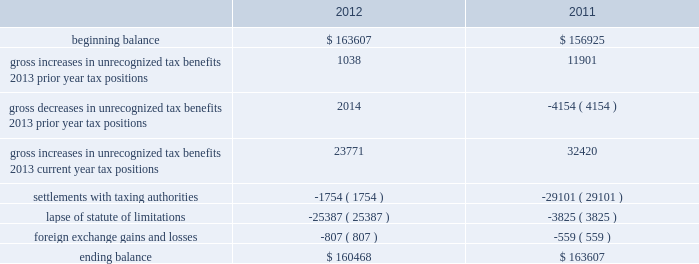Repatriated , the related u.s .
Tax liability may be reduced by any foreign income taxes paid on these earnings .
As of november 30 , 2012 , the cumulative amount of earnings upon which u.s .
Income taxes have not been provided is approximately $ 2.9 billion .
The unrecognized deferred tax liability for these earnings is approximately $ 0.8 billion .
As of november 30 , 2012 , we have u.s .
Net operating loss carryforwards of approximately $ 33.7 million for federal and $ 77.7 million for state .
We also have federal , state and foreign tax credit carryforwards of approximately $ 1.9 million , $ 18.0 million and $ 17.6 million , respectively .
The net operating loss carryforward assets , federal tax credits and foreign tax credits will expire in various years from fiscal 2017 through 2032 .
The state tax credit carryforwards can be carried forward indefinitely .
The net operating loss carryforward assets and certain credits are subject to an annual limitation under internal revenue code section 382 , but are expected to be fully realized .
In addition , we have been tracking certain deferred tax attributes of $ 45.0 million which have not been recorded in the financial statements pursuant to accounting standards related to stock-based compensation .
These amounts are no longer included in our gross or net deferred tax assets .
Pursuant to these standards , the benefit of these deferred tax assets will be recorded to equity if and when they reduce taxes payable .
As of november 30 , 2012 , a valuation allowance of $ 28.2 million has been established for certain deferred tax assets related to the impairment of investments and certain foreign assets .
For fiscal 2012 , the total change in the valuation allowance was $ 23.0 million , of which $ 2.1 million was recorded as a tax benefit through the income statement .
Accounting for uncertainty in income taxes during fiscal 2012 and 2011 , our aggregate changes in our total gross amount of unrecognized tax benefits are summarized as follows ( in thousands ) : .
As of november 30 , 2012 , the combined amount of accrued interest and penalties related to tax positions taken on our tax returns and included in non-current income taxes payable was approximately $ 12.5 million .
We file income tax returns in the u.s .
On a federal basis and in many u.s .
State and foreign jurisdictions .
We are subject to the continual examination of our income tax returns by the irs and other domestic and foreign tax authorities .
Our major tax jurisdictions are the u.s. , ireland and california .
For california , ireland and the u.s. , the earliest fiscal years open for examination are 2005 , 2006 and 2008 , respectively .
We regularly assess the likelihood of outcomes resulting from these examinations to determine the adequacy of our provision for income taxes and have reserved for potential adjustments that may result from the current examinations .
We believe such estimates to be reasonable ; however , there can be no assurance that the final determination of any of these examinations will not have an adverse effect on our operating results and financial position .
In august 2011 , a canadian income tax examination covering our fiscal years 2005 through 2008 was completed .
Our accrued tax and interest related to these years was approximately $ 35 million and was previously reported in long-term income taxes payable .
We reclassified approximately $ 17 million to short-term income taxes payable and decreased deferred tax assets by approximately $ 18 million in conjunction with the aforementioned resolution .
The timing of the resolution of income tax examinations is highly uncertain as are the amounts and timing of tax payments that are part of any audit settlement process .
These events could cause large fluctuations in the balance sheet classification of current and non-current assets and liabilities .
The company believes that before the end of fiscal 2013 , it is reasonably possible table of contents adobe systems incorporated notes to consolidated financial statements ( continued ) .
What is the percentage change in total gross amount of unrecognized tax benefits from 2011 to 2012? 
Computations: ((160468 - 163607) / 163607)
Answer: -0.01919. 